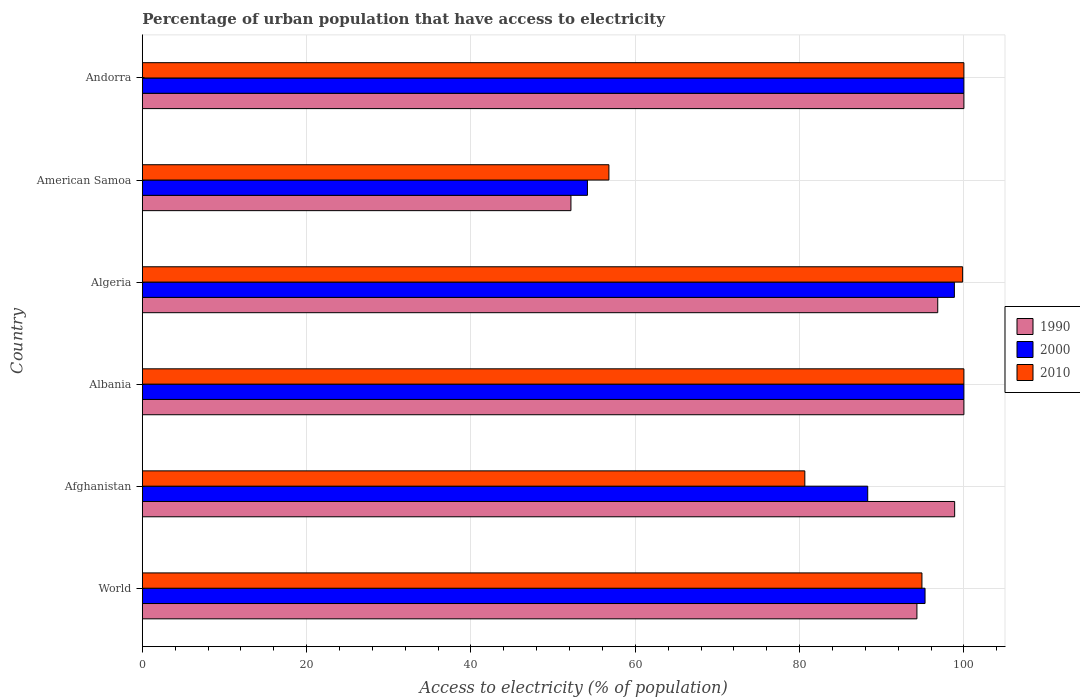Are the number of bars on each tick of the Y-axis equal?
Your answer should be very brief. Yes. How many bars are there on the 6th tick from the top?
Ensure brevity in your answer.  3. What is the label of the 5th group of bars from the top?
Provide a short and direct response. Afghanistan. In how many cases, is the number of bars for a given country not equal to the number of legend labels?
Ensure brevity in your answer.  0. What is the percentage of urban population that have access to electricity in 1990 in Afghanistan?
Offer a very short reply. 98.87. Across all countries, what is the minimum percentage of urban population that have access to electricity in 2000?
Your answer should be compact. 54.18. In which country was the percentage of urban population that have access to electricity in 1990 maximum?
Provide a succinct answer. Albania. In which country was the percentage of urban population that have access to electricity in 2000 minimum?
Make the answer very short. American Samoa. What is the total percentage of urban population that have access to electricity in 2010 in the graph?
Your response must be concise. 532.16. What is the difference between the percentage of urban population that have access to electricity in 2000 in Afghanistan and that in Algeria?
Your answer should be compact. -10.55. What is the difference between the percentage of urban population that have access to electricity in 1990 in Algeria and the percentage of urban population that have access to electricity in 2000 in Albania?
Your answer should be very brief. -3.19. What is the average percentage of urban population that have access to electricity in 1990 per country?
Keep it short and to the point. 90.36. What is the difference between the percentage of urban population that have access to electricity in 2000 and percentage of urban population that have access to electricity in 2010 in Algeria?
Your response must be concise. -1.01. What is the ratio of the percentage of urban population that have access to electricity in 1990 in Afghanistan to that in American Samoa?
Make the answer very short. 1.9. Is the difference between the percentage of urban population that have access to electricity in 2000 in Andorra and World greater than the difference between the percentage of urban population that have access to electricity in 2010 in Andorra and World?
Ensure brevity in your answer.  No. What is the difference between the highest and the lowest percentage of urban population that have access to electricity in 1990?
Your response must be concise. 47.83. In how many countries, is the percentage of urban population that have access to electricity in 2000 greater than the average percentage of urban population that have access to electricity in 2000 taken over all countries?
Your answer should be very brief. 4. Is the sum of the percentage of urban population that have access to electricity in 1990 in Albania and American Samoa greater than the maximum percentage of urban population that have access to electricity in 2000 across all countries?
Offer a very short reply. Yes. What does the 1st bar from the top in Algeria represents?
Offer a terse response. 2010. How many bars are there?
Your answer should be very brief. 18. Are all the bars in the graph horizontal?
Keep it short and to the point. Yes. How many countries are there in the graph?
Give a very brief answer. 6. What is the difference between two consecutive major ticks on the X-axis?
Keep it short and to the point. 20. Does the graph contain grids?
Your response must be concise. Yes. Where does the legend appear in the graph?
Ensure brevity in your answer.  Center right. How many legend labels are there?
Your answer should be very brief. 3. What is the title of the graph?
Keep it short and to the point. Percentage of urban population that have access to electricity. Does "1983" appear as one of the legend labels in the graph?
Give a very brief answer. No. What is the label or title of the X-axis?
Give a very brief answer. Access to electricity (% of population). What is the label or title of the Y-axis?
Your response must be concise. Country. What is the Access to electricity (% of population) in 1990 in World?
Provide a succinct answer. 94.28. What is the Access to electricity (% of population) in 2000 in World?
Provide a short and direct response. 95.27. What is the Access to electricity (% of population) of 2010 in World?
Keep it short and to the point. 94.89. What is the Access to electricity (% of population) in 1990 in Afghanistan?
Your answer should be compact. 98.87. What is the Access to electricity (% of population) of 2000 in Afghanistan?
Offer a very short reply. 88.29. What is the Access to electricity (% of population) in 2010 in Afghanistan?
Ensure brevity in your answer.  80.64. What is the Access to electricity (% of population) in 1990 in Algeria?
Provide a short and direct response. 96.81. What is the Access to electricity (% of population) of 2000 in Algeria?
Give a very brief answer. 98.84. What is the Access to electricity (% of population) of 2010 in Algeria?
Offer a terse response. 99.84. What is the Access to electricity (% of population) of 1990 in American Samoa?
Make the answer very short. 52.17. What is the Access to electricity (% of population) in 2000 in American Samoa?
Keep it short and to the point. 54.18. What is the Access to electricity (% of population) in 2010 in American Samoa?
Ensure brevity in your answer.  56.79. What is the Access to electricity (% of population) in 1990 in Andorra?
Your answer should be compact. 100. What is the Access to electricity (% of population) of 2010 in Andorra?
Keep it short and to the point. 100. Across all countries, what is the minimum Access to electricity (% of population) in 1990?
Offer a terse response. 52.17. Across all countries, what is the minimum Access to electricity (% of population) of 2000?
Offer a very short reply. 54.18. Across all countries, what is the minimum Access to electricity (% of population) of 2010?
Your answer should be very brief. 56.79. What is the total Access to electricity (% of population) of 1990 in the graph?
Your answer should be very brief. 542.13. What is the total Access to electricity (% of population) of 2000 in the graph?
Give a very brief answer. 536.58. What is the total Access to electricity (% of population) of 2010 in the graph?
Keep it short and to the point. 532.16. What is the difference between the Access to electricity (% of population) in 1990 in World and that in Afghanistan?
Provide a short and direct response. -4.59. What is the difference between the Access to electricity (% of population) in 2000 in World and that in Afghanistan?
Offer a terse response. 6.98. What is the difference between the Access to electricity (% of population) of 2010 in World and that in Afghanistan?
Your answer should be very brief. 14.25. What is the difference between the Access to electricity (% of population) of 1990 in World and that in Albania?
Offer a very short reply. -5.72. What is the difference between the Access to electricity (% of population) in 2000 in World and that in Albania?
Provide a succinct answer. -4.73. What is the difference between the Access to electricity (% of population) in 2010 in World and that in Albania?
Make the answer very short. -5.11. What is the difference between the Access to electricity (% of population) of 1990 in World and that in Algeria?
Your answer should be very brief. -2.53. What is the difference between the Access to electricity (% of population) in 2000 in World and that in Algeria?
Offer a terse response. -3.57. What is the difference between the Access to electricity (% of population) of 2010 in World and that in Algeria?
Offer a terse response. -4.95. What is the difference between the Access to electricity (% of population) of 1990 in World and that in American Samoa?
Keep it short and to the point. 42.11. What is the difference between the Access to electricity (% of population) in 2000 in World and that in American Samoa?
Keep it short and to the point. 41.09. What is the difference between the Access to electricity (% of population) of 2010 in World and that in American Samoa?
Give a very brief answer. 38.1. What is the difference between the Access to electricity (% of population) in 1990 in World and that in Andorra?
Keep it short and to the point. -5.72. What is the difference between the Access to electricity (% of population) in 2000 in World and that in Andorra?
Provide a short and direct response. -4.73. What is the difference between the Access to electricity (% of population) of 2010 in World and that in Andorra?
Make the answer very short. -5.11. What is the difference between the Access to electricity (% of population) in 1990 in Afghanistan and that in Albania?
Give a very brief answer. -1.13. What is the difference between the Access to electricity (% of population) in 2000 in Afghanistan and that in Albania?
Ensure brevity in your answer.  -11.71. What is the difference between the Access to electricity (% of population) of 2010 in Afghanistan and that in Albania?
Ensure brevity in your answer.  -19.36. What is the difference between the Access to electricity (% of population) of 1990 in Afghanistan and that in Algeria?
Offer a very short reply. 2.06. What is the difference between the Access to electricity (% of population) of 2000 in Afghanistan and that in Algeria?
Your answer should be very brief. -10.55. What is the difference between the Access to electricity (% of population) of 2010 in Afghanistan and that in Algeria?
Keep it short and to the point. -19.21. What is the difference between the Access to electricity (% of population) of 1990 in Afghanistan and that in American Samoa?
Your answer should be very brief. 46.7. What is the difference between the Access to electricity (% of population) in 2000 in Afghanistan and that in American Samoa?
Offer a terse response. 34.11. What is the difference between the Access to electricity (% of population) in 2010 in Afghanistan and that in American Samoa?
Ensure brevity in your answer.  23.85. What is the difference between the Access to electricity (% of population) of 1990 in Afghanistan and that in Andorra?
Provide a short and direct response. -1.13. What is the difference between the Access to electricity (% of population) in 2000 in Afghanistan and that in Andorra?
Offer a very short reply. -11.71. What is the difference between the Access to electricity (% of population) of 2010 in Afghanistan and that in Andorra?
Give a very brief answer. -19.36. What is the difference between the Access to electricity (% of population) of 1990 in Albania and that in Algeria?
Keep it short and to the point. 3.19. What is the difference between the Access to electricity (% of population) in 2000 in Albania and that in Algeria?
Your answer should be compact. 1.16. What is the difference between the Access to electricity (% of population) in 2010 in Albania and that in Algeria?
Make the answer very short. 0.16. What is the difference between the Access to electricity (% of population) of 1990 in Albania and that in American Samoa?
Ensure brevity in your answer.  47.83. What is the difference between the Access to electricity (% of population) of 2000 in Albania and that in American Samoa?
Keep it short and to the point. 45.82. What is the difference between the Access to electricity (% of population) in 2010 in Albania and that in American Samoa?
Your answer should be compact. 43.21. What is the difference between the Access to electricity (% of population) in 1990 in Albania and that in Andorra?
Provide a short and direct response. 0. What is the difference between the Access to electricity (% of population) in 2000 in Albania and that in Andorra?
Your response must be concise. 0. What is the difference between the Access to electricity (% of population) in 2010 in Albania and that in Andorra?
Offer a very short reply. 0. What is the difference between the Access to electricity (% of population) in 1990 in Algeria and that in American Samoa?
Provide a short and direct response. 44.65. What is the difference between the Access to electricity (% of population) of 2000 in Algeria and that in American Samoa?
Provide a short and direct response. 44.66. What is the difference between the Access to electricity (% of population) of 2010 in Algeria and that in American Samoa?
Give a very brief answer. 43.05. What is the difference between the Access to electricity (% of population) in 1990 in Algeria and that in Andorra?
Your response must be concise. -3.19. What is the difference between the Access to electricity (% of population) of 2000 in Algeria and that in Andorra?
Your answer should be very brief. -1.16. What is the difference between the Access to electricity (% of population) of 2010 in Algeria and that in Andorra?
Keep it short and to the point. -0.16. What is the difference between the Access to electricity (% of population) in 1990 in American Samoa and that in Andorra?
Offer a very short reply. -47.83. What is the difference between the Access to electricity (% of population) in 2000 in American Samoa and that in Andorra?
Ensure brevity in your answer.  -45.82. What is the difference between the Access to electricity (% of population) of 2010 in American Samoa and that in Andorra?
Your answer should be compact. -43.21. What is the difference between the Access to electricity (% of population) of 1990 in World and the Access to electricity (% of population) of 2000 in Afghanistan?
Ensure brevity in your answer.  5.99. What is the difference between the Access to electricity (% of population) of 1990 in World and the Access to electricity (% of population) of 2010 in Afghanistan?
Your response must be concise. 13.64. What is the difference between the Access to electricity (% of population) of 2000 in World and the Access to electricity (% of population) of 2010 in Afghanistan?
Offer a very short reply. 14.63. What is the difference between the Access to electricity (% of population) in 1990 in World and the Access to electricity (% of population) in 2000 in Albania?
Your answer should be very brief. -5.72. What is the difference between the Access to electricity (% of population) in 1990 in World and the Access to electricity (% of population) in 2010 in Albania?
Provide a succinct answer. -5.72. What is the difference between the Access to electricity (% of population) in 2000 in World and the Access to electricity (% of population) in 2010 in Albania?
Offer a very short reply. -4.73. What is the difference between the Access to electricity (% of population) of 1990 in World and the Access to electricity (% of population) of 2000 in Algeria?
Your response must be concise. -4.56. What is the difference between the Access to electricity (% of population) in 1990 in World and the Access to electricity (% of population) in 2010 in Algeria?
Provide a short and direct response. -5.56. What is the difference between the Access to electricity (% of population) in 2000 in World and the Access to electricity (% of population) in 2010 in Algeria?
Your response must be concise. -4.57. What is the difference between the Access to electricity (% of population) in 1990 in World and the Access to electricity (% of population) in 2000 in American Samoa?
Provide a succinct answer. 40.1. What is the difference between the Access to electricity (% of population) of 1990 in World and the Access to electricity (% of population) of 2010 in American Samoa?
Make the answer very short. 37.49. What is the difference between the Access to electricity (% of population) in 2000 in World and the Access to electricity (% of population) in 2010 in American Samoa?
Your response must be concise. 38.48. What is the difference between the Access to electricity (% of population) of 1990 in World and the Access to electricity (% of population) of 2000 in Andorra?
Make the answer very short. -5.72. What is the difference between the Access to electricity (% of population) of 1990 in World and the Access to electricity (% of population) of 2010 in Andorra?
Keep it short and to the point. -5.72. What is the difference between the Access to electricity (% of population) of 2000 in World and the Access to electricity (% of population) of 2010 in Andorra?
Offer a very short reply. -4.73. What is the difference between the Access to electricity (% of population) of 1990 in Afghanistan and the Access to electricity (% of population) of 2000 in Albania?
Your response must be concise. -1.13. What is the difference between the Access to electricity (% of population) of 1990 in Afghanistan and the Access to electricity (% of population) of 2010 in Albania?
Provide a short and direct response. -1.13. What is the difference between the Access to electricity (% of population) in 2000 in Afghanistan and the Access to electricity (% of population) in 2010 in Albania?
Your response must be concise. -11.71. What is the difference between the Access to electricity (% of population) in 1990 in Afghanistan and the Access to electricity (% of population) in 2000 in Algeria?
Offer a terse response. 0.03. What is the difference between the Access to electricity (% of population) of 1990 in Afghanistan and the Access to electricity (% of population) of 2010 in Algeria?
Ensure brevity in your answer.  -0.97. What is the difference between the Access to electricity (% of population) in 2000 in Afghanistan and the Access to electricity (% of population) in 2010 in Algeria?
Offer a terse response. -11.55. What is the difference between the Access to electricity (% of population) in 1990 in Afghanistan and the Access to electricity (% of population) in 2000 in American Samoa?
Your answer should be very brief. 44.7. What is the difference between the Access to electricity (% of population) in 1990 in Afghanistan and the Access to electricity (% of population) in 2010 in American Samoa?
Provide a succinct answer. 42.08. What is the difference between the Access to electricity (% of population) in 2000 in Afghanistan and the Access to electricity (% of population) in 2010 in American Samoa?
Offer a very short reply. 31.5. What is the difference between the Access to electricity (% of population) in 1990 in Afghanistan and the Access to electricity (% of population) in 2000 in Andorra?
Give a very brief answer. -1.13. What is the difference between the Access to electricity (% of population) in 1990 in Afghanistan and the Access to electricity (% of population) in 2010 in Andorra?
Your answer should be compact. -1.13. What is the difference between the Access to electricity (% of population) of 2000 in Afghanistan and the Access to electricity (% of population) of 2010 in Andorra?
Your response must be concise. -11.71. What is the difference between the Access to electricity (% of population) in 1990 in Albania and the Access to electricity (% of population) in 2000 in Algeria?
Keep it short and to the point. 1.16. What is the difference between the Access to electricity (% of population) in 1990 in Albania and the Access to electricity (% of population) in 2010 in Algeria?
Make the answer very short. 0.16. What is the difference between the Access to electricity (% of population) of 2000 in Albania and the Access to electricity (% of population) of 2010 in Algeria?
Provide a short and direct response. 0.16. What is the difference between the Access to electricity (% of population) of 1990 in Albania and the Access to electricity (% of population) of 2000 in American Samoa?
Offer a very short reply. 45.82. What is the difference between the Access to electricity (% of population) in 1990 in Albania and the Access to electricity (% of population) in 2010 in American Samoa?
Provide a short and direct response. 43.21. What is the difference between the Access to electricity (% of population) of 2000 in Albania and the Access to electricity (% of population) of 2010 in American Samoa?
Make the answer very short. 43.21. What is the difference between the Access to electricity (% of population) in 1990 in Albania and the Access to electricity (% of population) in 2000 in Andorra?
Offer a very short reply. 0. What is the difference between the Access to electricity (% of population) in 1990 in Algeria and the Access to electricity (% of population) in 2000 in American Samoa?
Give a very brief answer. 42.64. What is the difference between the Access to electricity (% of population) in 1990 in Algeria and the Access to electricity (% of population) in 2010 in American Samoa?
Offer a very short reply. 40.02. What is the difference between the Access to electricity (% of population) in 2000 in Algeria and the Access to electricity (% of population) in 2010 in American Samoa?
Ensure brevity in your answer.  42.05. What is the difference between the Access to electricity (% of population) in 1990 in Algeria and the Access to electricity (% of population) in 2000 in Andorra?
Your answer should be very brief. -3.19. What is the difference between the Access to electricity (% of population) of 1990 in Algeria and the Access to electricity (% of population) of 2010 in Andorra?
Provide a succinct answer. -3.19. What is the difference between the Access to electricity (% of population) in 2000 in Algeria and the Access to electricity (% of population) in 2010 in Andorra?
Your answer should be compact. -1.16. What is the difference between the Access to electricity (% of population) of 1990 in American Samoa and the Access to electricity (% of population) of 2000 in Andorra?
Offer a terse response. -47.83. What is the difference between the Access to electricity (% of population) in 1990 in American Samoa and the Access to electricity (% of population) in 2010 in Andorra?
Offer a terse response. -47.83. What is the difference between the Access to electricity (% of population) of 2000 in American Samoa and the Access to electricity (% of population) of 2010 in Andorra?
Make the answer very short. -45.82. What is the average Access to electricity (% of population) in 1990 per country?
Your response must be concise. 90.36. What is the average Access to electricity (% of population) in 2000 per country?
Make the answer very short. 89.43. What is the average Access to electricity (% of population) of 2010 per country?
Offer a terse response. 88.69. What is the difference between the Access to electricity (% of population) of 1990 and Access to electricity (% of population) of 2000 in World?
Make the answer very short. -0.99. What is the difference between the Access to electricity (% of population) of 1990 and Access to electricity (% of population) of 2010 in World?
Give a very brief answer. -0.61. What is the difference between the Access to electricity (% of population) in 2000 and Access to electricity (% of population) in 2010 in World?
Provide a succinct answer. 0.38. What is the difference between the Access to electricity (% of population) of 1990 and Access to electricity (% of population) of 2000 in Afghanistan?
Your answer should be compact. 10.58. What is the difference between the Access to electricity (% of population) in 1990 and Access to electricity (% of population) in 2010 in Afghanistan?
Your answer should be compact. 18.24. What is the difference between the Access to electricity (% of population) in 2000 and Access to electricity (% of population) in 2010 in Afghanistan?
Offer a terse response. 7.65. What is the difference between the Access to electricity (% of population) of 1990 and Access to electricity (% of population) of 2000 in Albania?
Provide a short and direct response. 0. What is the difference between the Access to electricity (% of population) in 1990 and Access to electricity (% of population) in 2010 in Albania?
Give a very brief answer. 0. What is the difference between the Access to electricity (% of population) in 1990 and Access to electricity (% of population) in 2000 in Algeria?
Provide a succinct answer. -2.02. What is the difference between the Access to electricity (% of population) in 1990 and Access to electricity (% of population) in 2010 in Algeria?
Provide a short and direct response. -3.03. What is the difference between the Access to electricity (% of population) in 2000 and Access to electricity (% of population) in 2010 in Algeria?
Ensure brevity in your answer.  -1.01. What is the difference between the Access to electricity (% of population) in 1990 and Access to electricity (% of population) in 2000 in American Samoa?
Offer a very short reply. -2.01. What is the difference between the Access to electricity (% of population) of 1990 and Access to electricity (% of population) of 2010 in American Samoa?
Offer a terse response. -4.62. What is the difference between the Access to electricity (% of population) of 2000 and Access to electricity (% of population) of 2010 in American Samoa?
Provide a succinct answer. -2.61. What is the difference between the Access to electricity (% of population) in 1990 and Access to electricity (% of population) in 2000 in Andorra?
Offer a very short reply. 0. What is the difference between the Access to electricity (% of population) of 1990 and Access to electricity (% of population) of 2010 in Andorra?
Keep it short and to the point. 0. What is the ratio of the Access to electricity (% of population) in 1990 in World to that in Afghanistan?
Give a very brief answer. 0.95. What is the ratio of the Access to electricity (% of population) in 2000 in World to that in Afghanistan?
Give a very brief answer. 1.08. What is the ratio of the Access to electricity (% of population) of 2010 in World to that in Afghanistan?
Make the answer very short. 1.18. What is the ratio of the Access to electricity (% of population) of 1990 in World to that in Albania?
Keep it short and to the point. 0.94. What is the ratio of the Access to electricity (% of population) of 2000 in World to that in Albania?
Offer a very short reply. 0.95. What is the ratio of the Access to electricity (% of population) of 2010 in World to that in Albania?
Give a very brief answer. 0.95. What is the ratio of the Access to electricity (% of population) of 1990 in World to that in Algeria?
Offer a terse response. 0.97. What is the ratio of the Access to electricity (% of population) in 2000 in World to that in Algeria?
Keep it short and to the point. 0.96. What is the ratio of the Access to electricity (% of population) of 2010 in World to that in Algeria?
Keep it short and to the point. 0.95. What is the ratio of the Access to electricity (% of population) of 1990 in World to that in American Samoa?
Provide a short and direct response. 1.81. What is the ratio of the Access to electricity (% of population) of 2000 in World to that in American Samoa?
Keep it short and to the point. 1.76. What is the ratio of the Access to electricity (% of population) in 2010 in World to that in American Samoa?
Your response must be concise. 1.67. What is the ratio of the Access to electricity (% of population) of 1990 in World to that in Andorra?
Give a very brief answer. 0.94. What is the ratio of the Access to electricity (% of population) in 2000 in World to that in Andorra?
Provide a short and direct response. 0.95. What is the ratio of the Access to electricity (% of population) of 2010 in World to that in Andorra?
Provide a short and direct response. 0.95. What is the ratio of the Access to electricity (% of population) in 1990 in Afghanistan to that in Albania?
Keep it short and to the point. 0.99. What is the ratio of the Access to electricity (% of population) of 2000 in Afghanistan to that in Albania?
Your response must be concise. 0.88. What is the ratio of the Access to electricity (% of population) in 2010 in Afghanistan to that in Albania?
Your answer should be very brief. 0.81. What is the ratio of the Access to electricity (% of population) of 1990 in Afghanistan to that in Algeria?
Your answer should be very brief. 1.02. What is the ratio of the Access to electricity (% of population) in 2000 in Afghanistan to that in Algeria?
Offer a terse response. 0.89. What is the ratio of the Access to electricity (% of population) in 2010 in Afghanistan to that in Algeria?
Give a very brief answer. 0.81. What is the ratio of the Access to electricity (% of population) of 1990 in Afghanistan to that in American Samoa?
Offer a terse response. 1.9. What is the ratio of the Access to electricity (% of population) in 2000 in Afghanistan to that in American Samoa?
Keep it short and to the point. 1.63. What is the ratio of the Access to electricity (% of population) of 2010 in Afghanistan to that in American Samoa?
Provide a short and direct response. 1.42. What is the ratio of the Access to electricity (% of population) in 1990 in Afghanistan to that in Andorra?
Provide a short and direct response. 0.99. What is the ratio of the Access to electricity (% of population) of 2000 in Afghanistan to that in Andorra?
Provide a short and direct response. 0.88. What is the ratio of the Access to electricity (% of population) in 2010 in Afghanistan to that in Andorra?
Offer a terse response. 0.81. What is the ratio of the Access to electricity (% of population) of 1990 in Albania to that in Algeria?
Your response must be concise. 1.03. What is the ratio of the Access to electricity (% of population) of 2000 in Albania to that in Algeria?
Offer a terse response. 1.01. What is the ratio of the Access to electricity (% of population) in 2010 in Albania to that in Algeria?
Your answer should be compact. 1. What is the ratio of the Access to electricity (% of population) of 1990 in Albania to that in American Samoa?
Provide a short and direct response. 1.92. What is the ratio of the Access to electricity (% of population) in 2000 in Albania to that in American Samoa?
Provide a short and direct response. 1.85. What is the ratio of the Access to electricity (% of population) in 2010 in Albania to that in American Samoa?
Your response must be concise. 1.76. What is the ratio of the Access to electricity (% of population) in 1990 in Albania to that in Andorra?
Make the answer very short. 1. What is the ratio of the Access to electricity (% of population) in 2000 in Albania to that in Andorra?
Keep it short and to the point. 1. What is the ratio of the Access to electricity (% of population) in 2010 in Albania to that in Andorra?
Ensure brevity in your answer.  1. What is the ratio of the Access to electricity (% of population) in 1990 in Algeria to that in American Samoa?
Provide a succinct answer. 1.86. What is the ratio of the Access to electricity (% of population) in 2000 in Algeria to that in American Samoa?
Your answer should be compact. 1.82. What is the ratio of the Access to electricity (% of population) in 2010 in Algeria to that in American Samoa?
Offer a very short reply. 1.76. What is the ratio of the Access to electricity (% of population) in 1990 in Algeria to that in Andorra?
Your response must be concise. 0.97. What is the ratio of the Access to electricity (% of population) in 2000 in Algeria to that in Andorra?
Offer a very short reply. 0.99. What is the ratio of the Access to electricity (% of population) in 1990 in American Samoa to that in Andorra?
Your answer should be very brief. 0.52. What is the ratio of the Access to electricity (% of population) in 2000 in American Samoa to that in Andorra?
Your answer should be very brief. 0.54. What is the ratio of the Access to electricity (% of population) in 2010 in American Samoa to that in Andorra?
Make the answer very short. 0.57. What is the difference between the highest and the second highest Access to electricity (% of population) of 1990?
Make the answer very short. 0. What is the difference between the highest and the second highest Access to electricity (% of population) of 2000?
Make the answer very short. 0. What is the difference between the highest and the lowest Access to electricity (% of population) in 1990?
Make the answer very short. 47.83. What is the difference between the highest and the lowest Access to electricity (% of population) of 2000?
Your response must be concise. 45.82. What is the difference between the highest and the lowest Access to electricity (% of population) in 2010?
Your answer should be very brief. 43.21. 